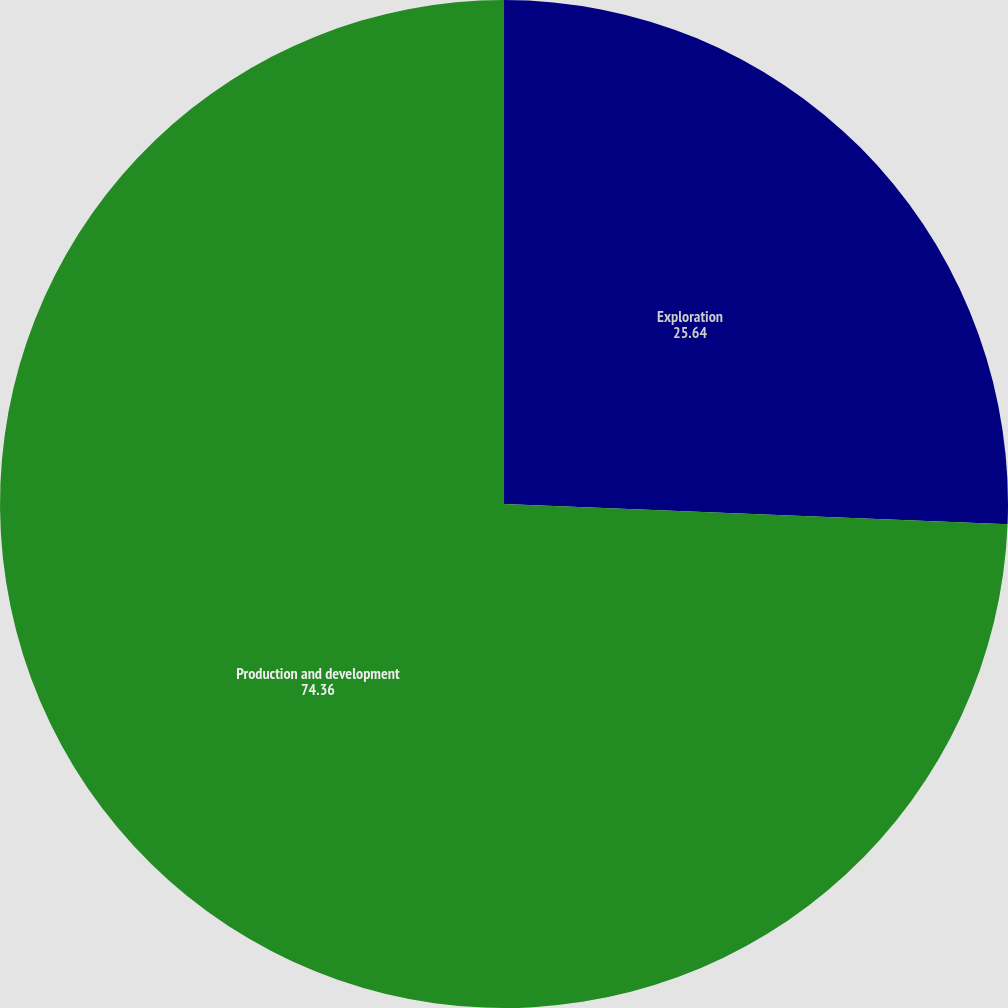Convert chart to OTSL. <chart><loc_0><loc_0><loc_500><loc_500><pie_chart><fcel>Exploration<fcel>Production and development<nl><fcel>25.64%<fcel>74.36%<nl></chart> 